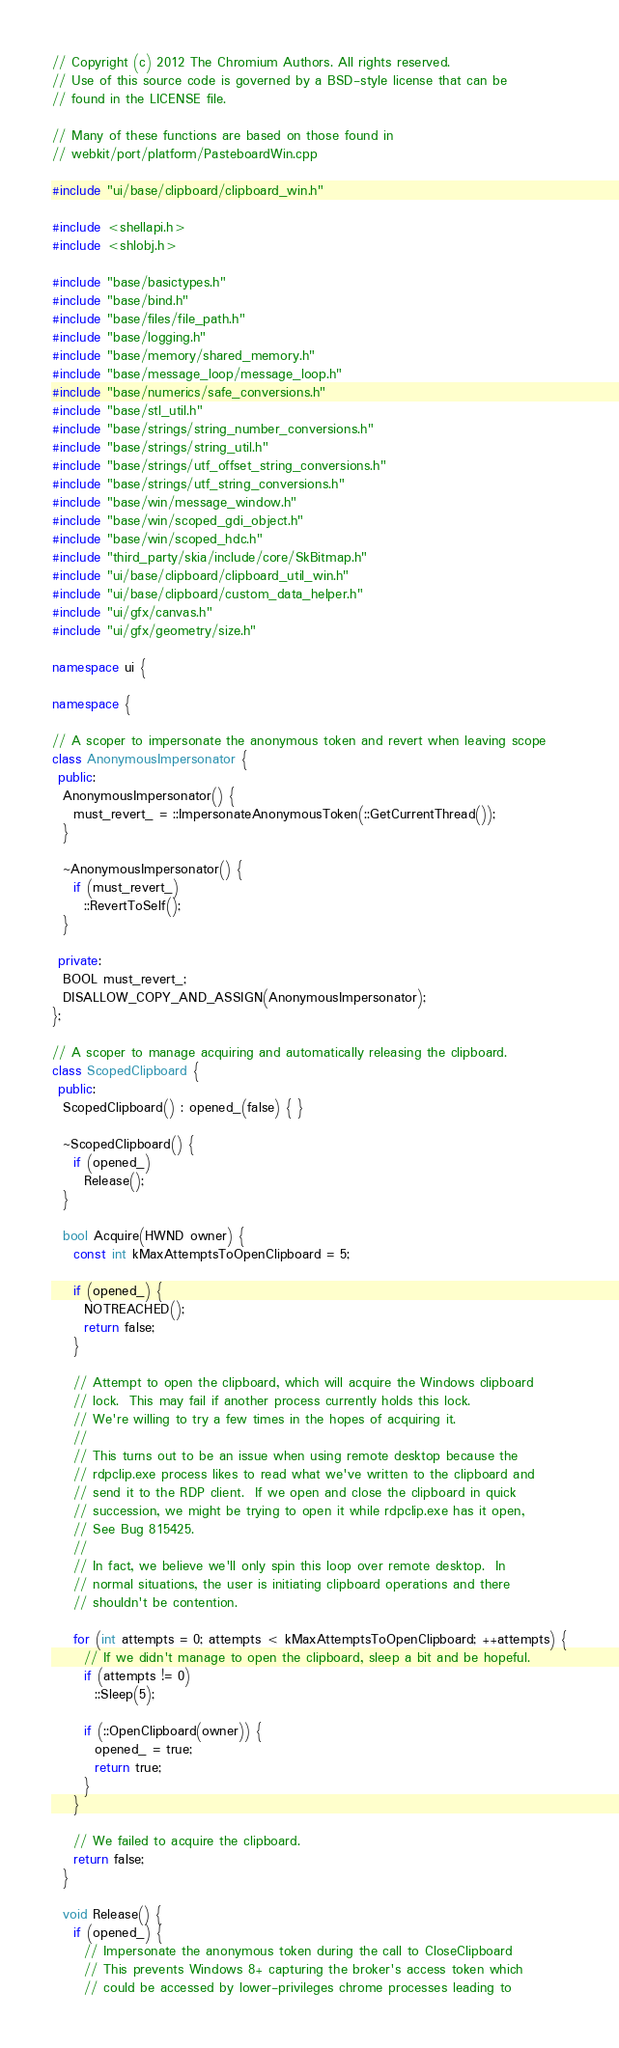Convert code to text. <code><loc_0><loc_0><loc_500><loc_500><_C++_>// Copyright (c) 2012 The Chromium Authors. All rights reserved.
// Use of this source code is governed by a BSD-style license that can be
// found in the LICENSE file.

// Many of these functions are based on those found in
// webkit/port/platform/PasteboardWin.cpp

#include "ui/base/clipboard/clipboard_win.h"

#include <shellapi.h>
#include <shlobj.h>

#include "base/basictypes.h"
#include "base/bind.h"
#include "base/files/file_path.h"
#include "base/logging.h"
#include "base/memory/shared_memory.h"
#include "base/message_loop/message_loop.h"
#include "base/numerics/safe_conversions.h"
#include "base/stl_util.h"
#include "base/strings/string_number_conversions.h"
#include "base/strings/string_util.h"
#include "base/strings/utf_offset_string_conversions.h"
#include "base/strings/utf_string_conversions.h"
#include "base/win/message_window.h"
#include "base/win/scoped_gdi_object.h"
#include "base/win/scoped_hdc.h"
#include "third_party/skia/include/core/SkBitmap.h"
#include "ui/base/clipboard/clipboard_util_win.h"
#include "ui/base/clipboard/custom_data_helper.h"
#include "ui/gfx/canvas.h"
#include "ui/gfx/geometry/size.h"

namespace ui {

namespace {

// A scoper to impersonate the anonymous token and revert when leaving scope
class AnonymousImpersonator {
 public:
  AnonymousImpersonator() {
    must_revert_ = ::ImpersonateAnonymousToken(::GetCurrentThread());
  }

  ~AnonymousImpersonator() {
    if (must_revert_)
      ::RevertToSelf();
  }

 private:
  BOOL must_revert_;
  DISALLOW_COPY_AND_ASSIGN(AnonymousImpersonator);
};

// A scoper to manage acquiring and automatically releasing the clipboard.
class ScopedClipboard {
 public:
  ScopedClipboard() : opened_(false) { }

  ~ScopedClipboard() {
    if (opened_)
      Release();
  }

  bool Acquire(HWND owner) {
    const int kMaxAttemptsToOpenClipboard = 5;

    if (opened_) {
      NOTREACHED();
      return false;
    }

    // Attempt to open the clipboard, which will acquire the Windows clipboard
    // lock.  This may fail if another process currently holds this lock.
    // We're willing to try a few times in the hopes of acquiring it.
    //
    // This turns out to be an issue when using remote desktop because the
    // rdpclip.exe process likes to read what we've written to the clipboard and
    // send it to the RDP client.  If we open and close the clipboard in quick
    // succession, we might be trying to open it while rdpclip.exe has it open,
    // See Bug 815425.
    //
    // In fact, we believe we'll only spin this loop over remote desktop.  In
    // normal situations, the user is initiating clipboard operations and there
    // shouldn't be contention.

    for (int attempts = 0; attempts < kMaxAttemptsToOpenClipboard; ++attempts) {
      // If we didn't manage to open the clipboard, sleep a bit and be hopeful.
      if (attempts != 0)
        ::Sleep(5);

      if (::OpenClipboard(owner)) {
        opened_ = true;
        return true;
      }
    }

    // We failed to acquire the clipboard.
    return false;
  }

  void Release() {
    if (opened_) {
      // Impersonate the anonymous token during the call to CloseClipboard
      // This prevents Windows 8+ capturing the broker's access token which
      // could be accessed by lower-privileges chrome processes leading to</code> 